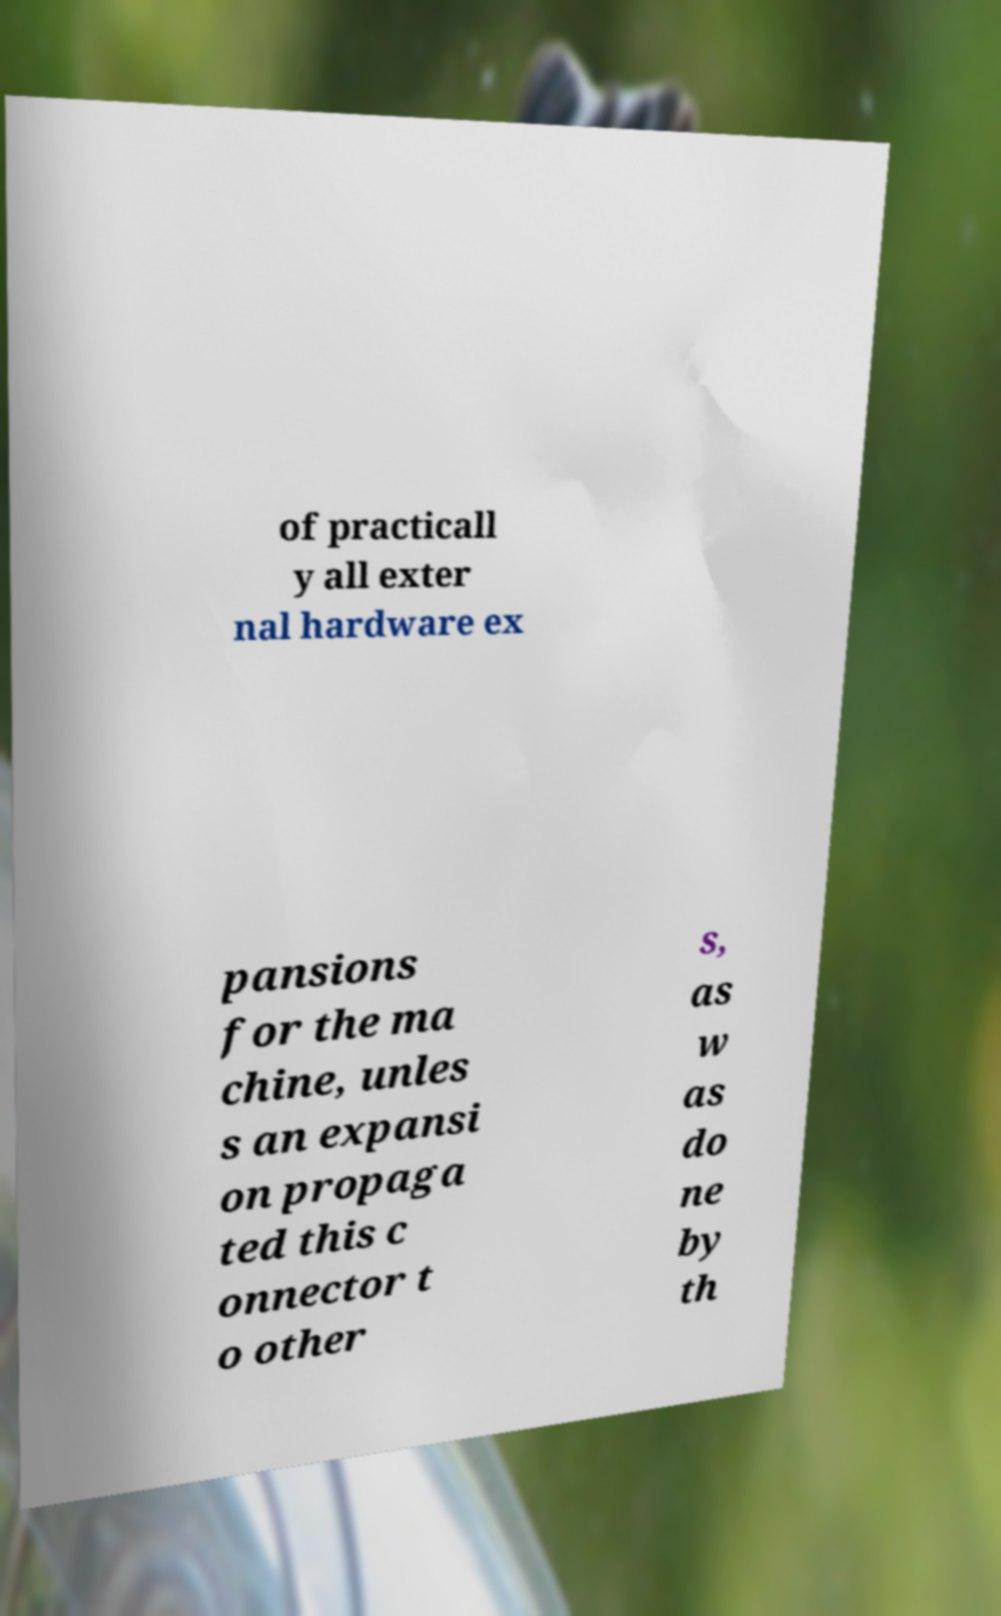Can you read and provide the text displayed in the image?This photo seems to have some interesting text. Can you extract and type it out for me? of practicall y all exter nal hardware ex pansions for the ma chine, unles s an expansi on propaga ted this c onnector t o other s, as w as do ne by th 